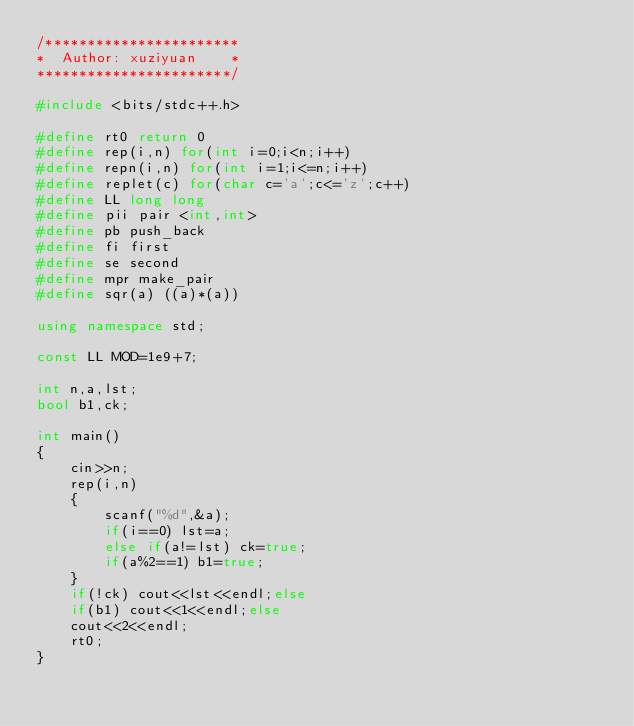<code> <loc_0><loc_0><loc_500><loc_500><_C++_>/***********************
*  Author: xuziyuan    * 
***********************/

#include <bits/stdc++.h>

#define rt0 return 0
#define rep(i,n) for(int i=0;i<n;i++)
#define repn(i,n) for(int i=1;i<=n;i++)
#define replet(c) for(char c='a';c<='z';c++) 
#define LL long long
#define pii pair <int,int>
#define pb push_back
#define fi first
#define se second
#define mpr make_pair
#define sqr(a) ((a)*(a))

using namespace std;

const LL MOD=1e9+7;

int n,a,lst;
bool b1,ck;

int main()
{
	cin>>n;
	rep(i,n)
	{
		scanf("%d",&a);
		if(i==0) lst=a;
		else if(a!=lst) ck=true;
		if(a%2==1) b1=true;
	}
	if(!ck) cout<<lst<<endl;else
	if(b1) cout<<1<<endl;else
	cout<<2<<endl;
	rt0;
}</code> 